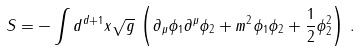<formula> <loc_0><loc_0><loc_500><loc_500>S = - \int d ^ { d + 1 } x \sqrt { g } \, \left ( \partial _ { \mu } \phi _ { 1 } \partial ^ { \mu } \phi _ { 2 } + m ^ { 2 } \phi _ { 1 } \phi _ { 2 } + \frac { 1 } { 2 } \phi _ { 2 } ^ { 2 } \right ) \, .</formula> 